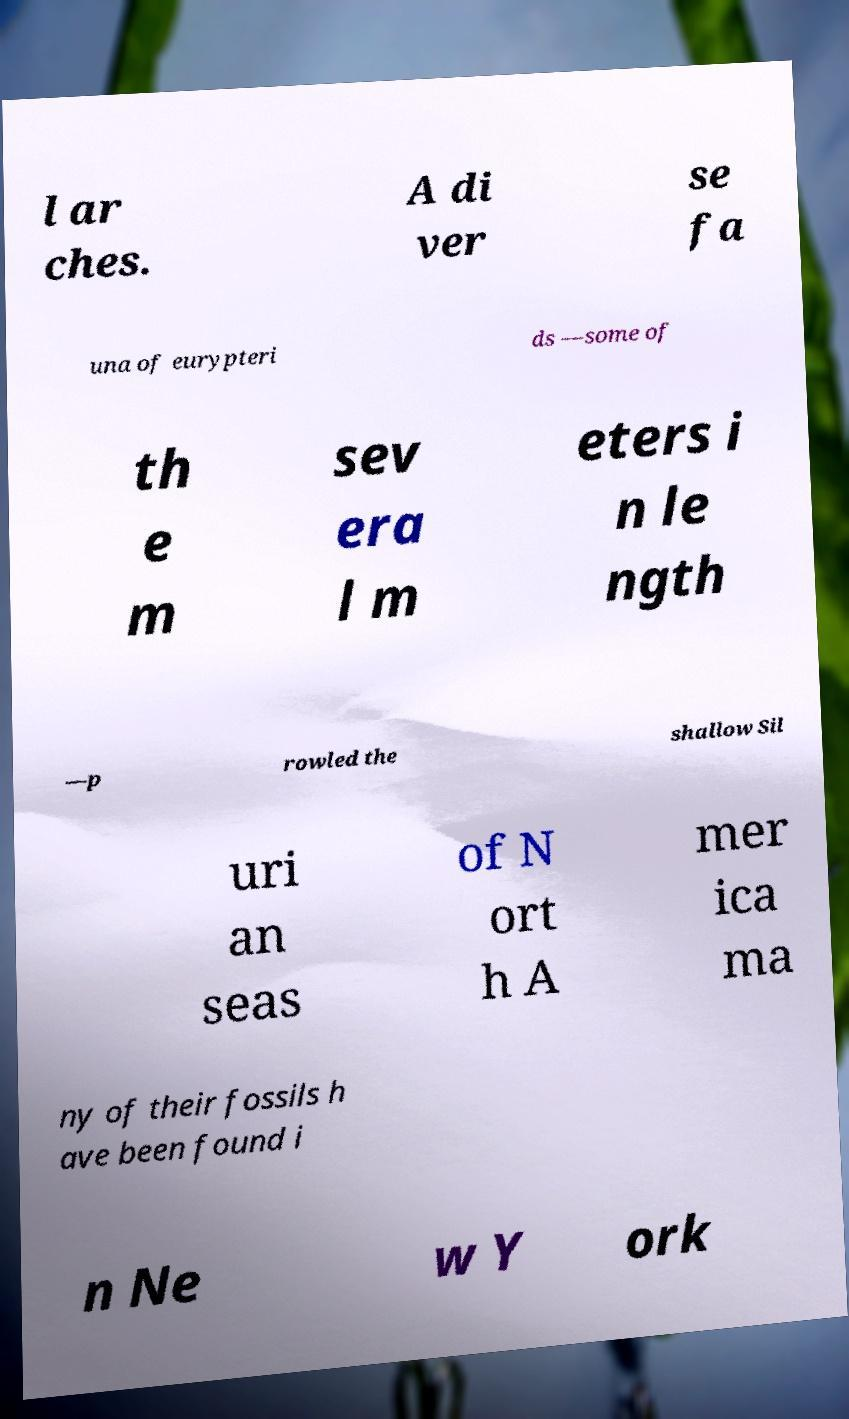Can you accurately transcribe the text from the provided image for me? l ar ches. A di ver se fa una of eurypteri ds —some of th e m sev era l m eters i n le ngth —p rowled the shallow Sil uri an seas of N ort h A mer ica ma ny of their fossils h ave been found i n Ne w Y ork 